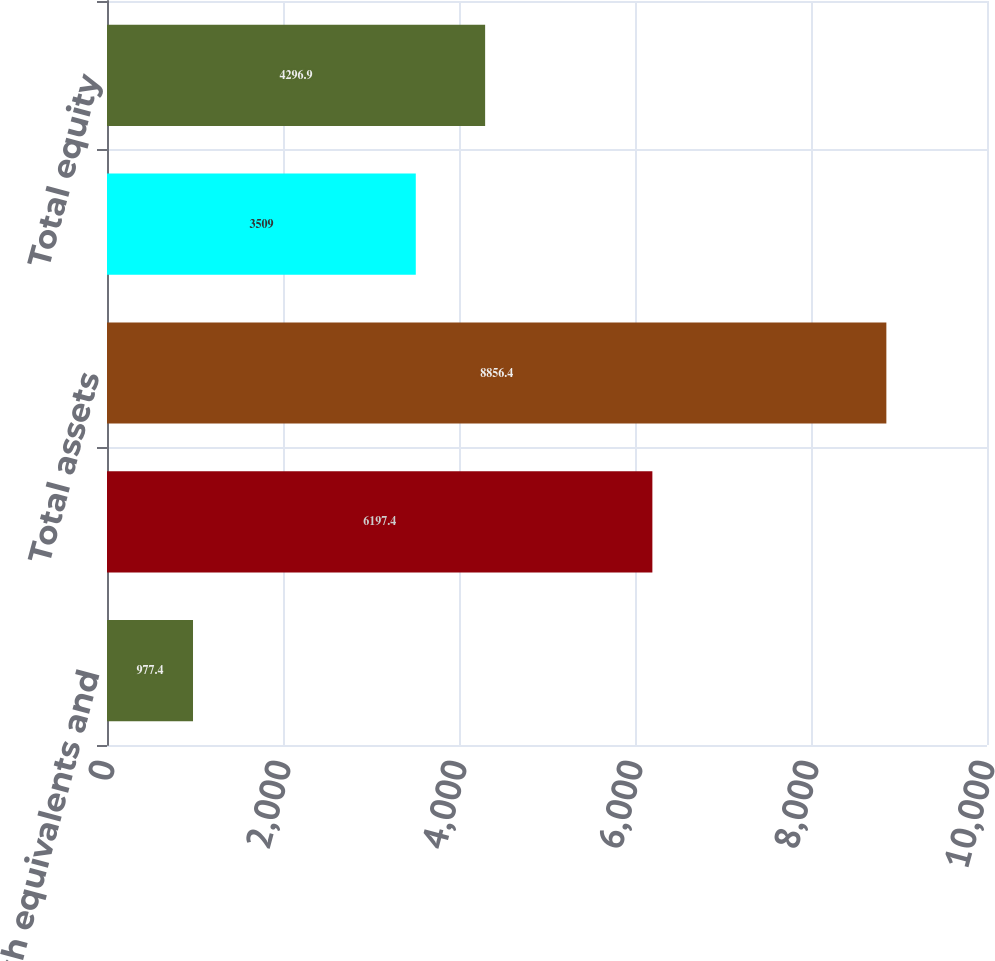Convert chart. <chart><loc_0><loc_0><loc_500><loc_500><bar_chart><fcel>Cash and cash equivalents and<fcel>Inventories<fcel>Total assets<fcel>Notes payable (4)<fcel>Total equity<nl><fcel>977.4<fcel>6197.4<fcel>8856.4<fcel>3509<fcel>4296.9<nl></chart> 